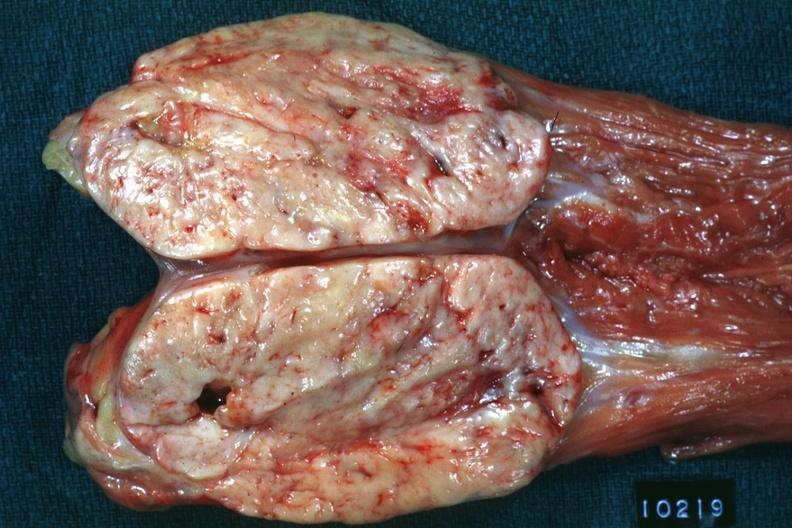does acute lymphocytic leukemia show opened muscle probably psoas natural color large ovoid typical sarcoma?
Answer the question using a single word or phrase. No 